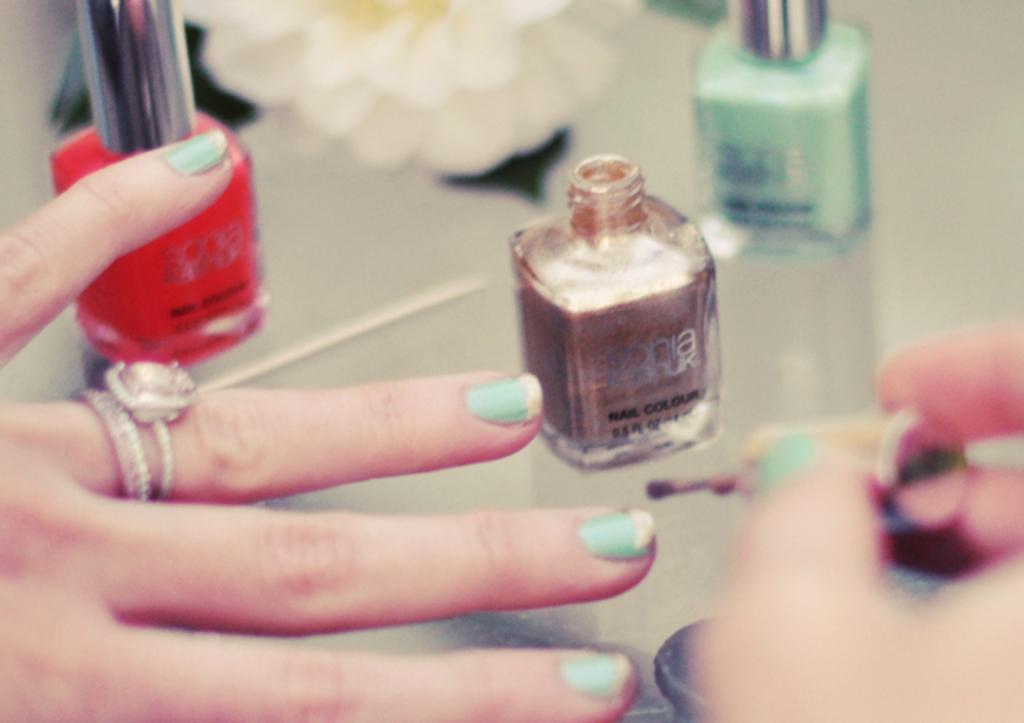<image>
Describe the image concisely. Three bottles of nail polish on a table and one says Nail Colour on it with a hand painting nails. 